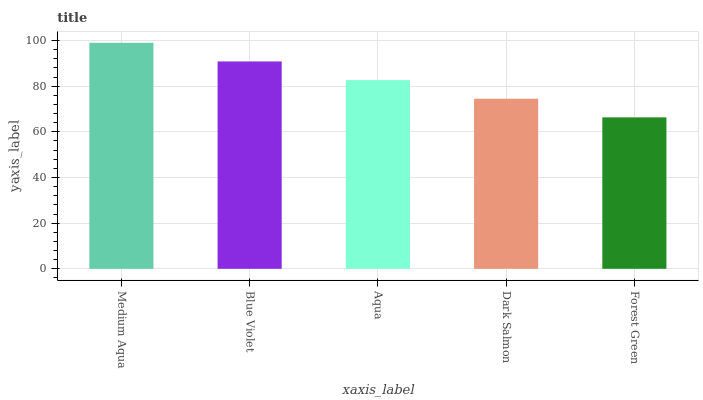Is Forest Green the minimum?
Answer yes or no. Yes. Is Medium Aqua the maximum?
Answer yes or no. Yes. Is Blue Violet the minimum?
Answer yes or no. No. Is Blue Violet the maximum?
Answer yes or no. No. Is Medium Aqua greater than Blue Violet?
Answer yes or no. Yes. Is Blue Violet less than Medium Aqua?
Answer yes or no. Yes. Is Blue Violet greater than Medium Aqua?
Answer yes or no. No. Is Medium Aqua less than Blue Violet?
Answer yes or no. No. Is Aqua the high median?
Answer yes or no. Yes. Is Aqua the low median?
Answer yes or no. Yes. Is Forest Green the high median?
Answer yes or no. No. Is Blue Violet the low median?
Answer yes or no. No. 